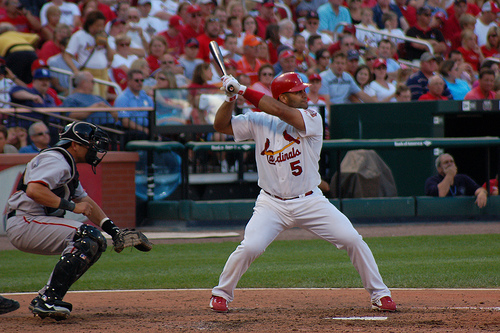How many people are swinging a bat? 1 